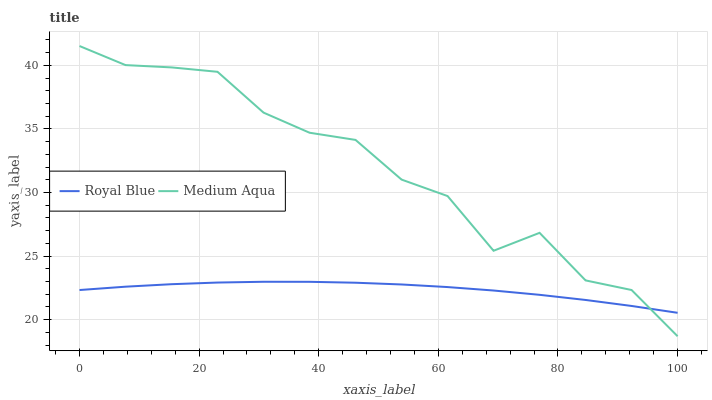Does Medium Aqua have the minimum area under the curve?
Answer yes or no. No. Is Medium Aqua the smoothest?
Answer yes or no. No. 